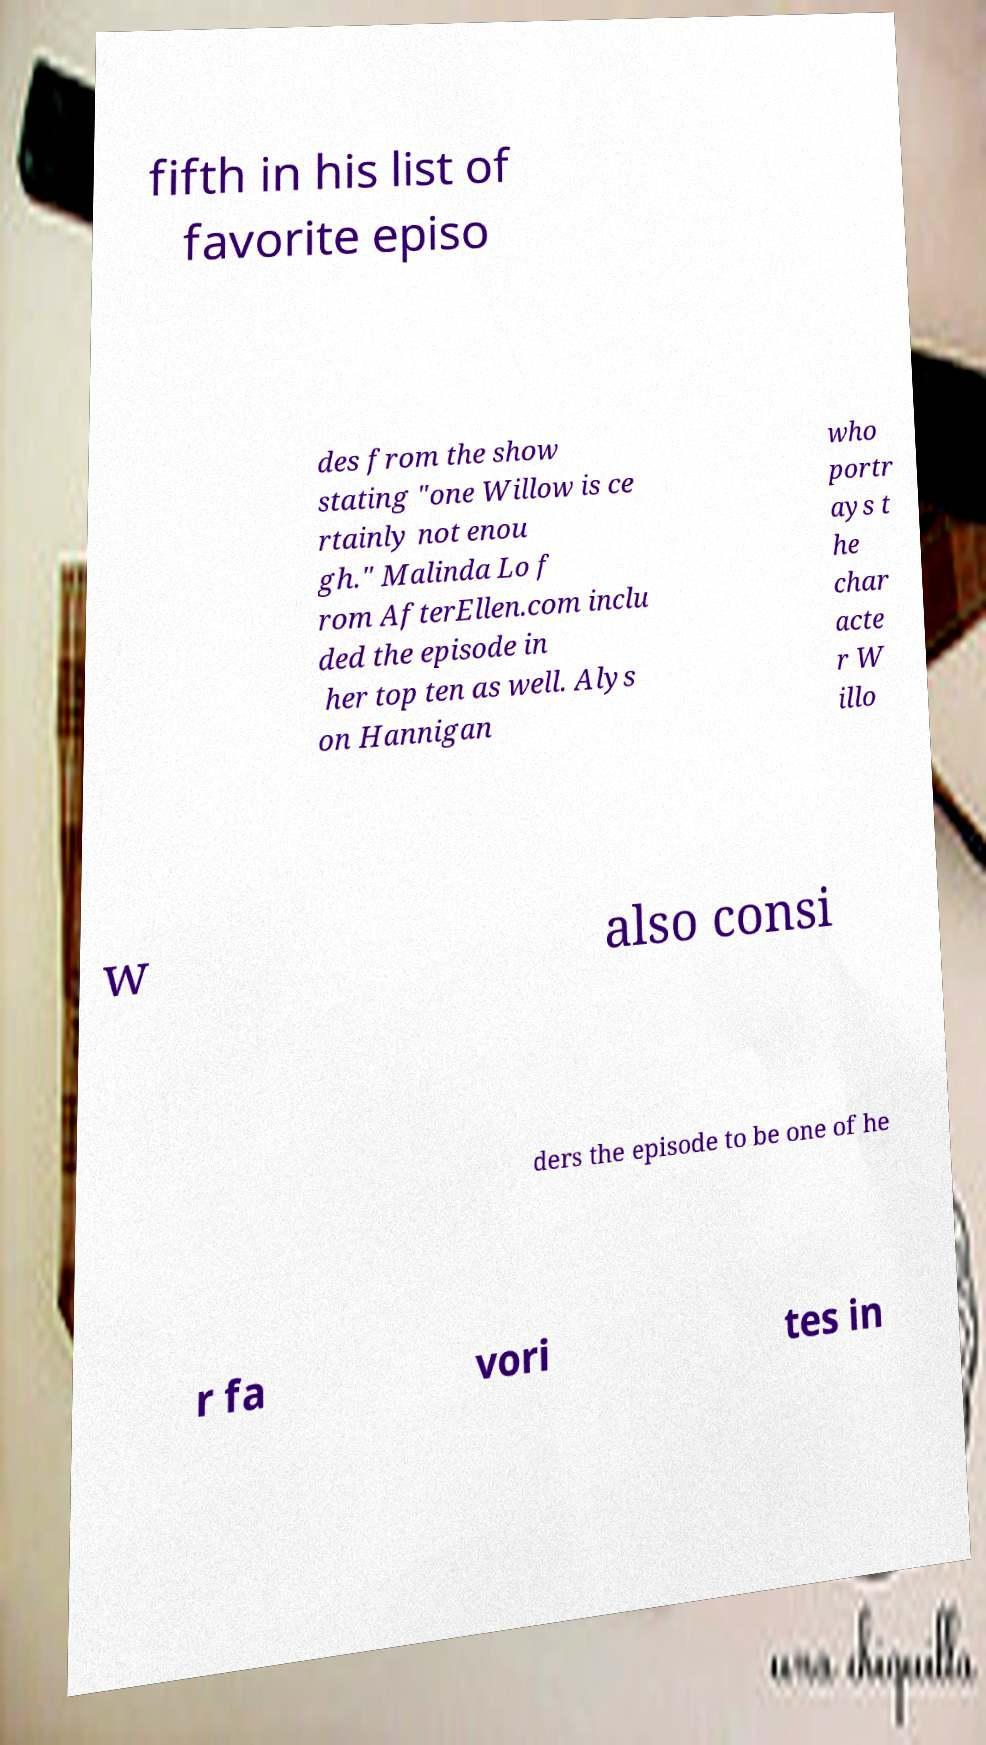Could you extract and type out the text from this image? fifth in his list of favorite episo des from the show stating "one Willow is ce rtainly not enou gh." Malinda Lo f rom AfterEllen.com inclu ded the episode in her top ten as well. Alys on Hannigan who portr ays t he char acte r W illo w also consi ders the episode to be one of he r fa vori tes in 